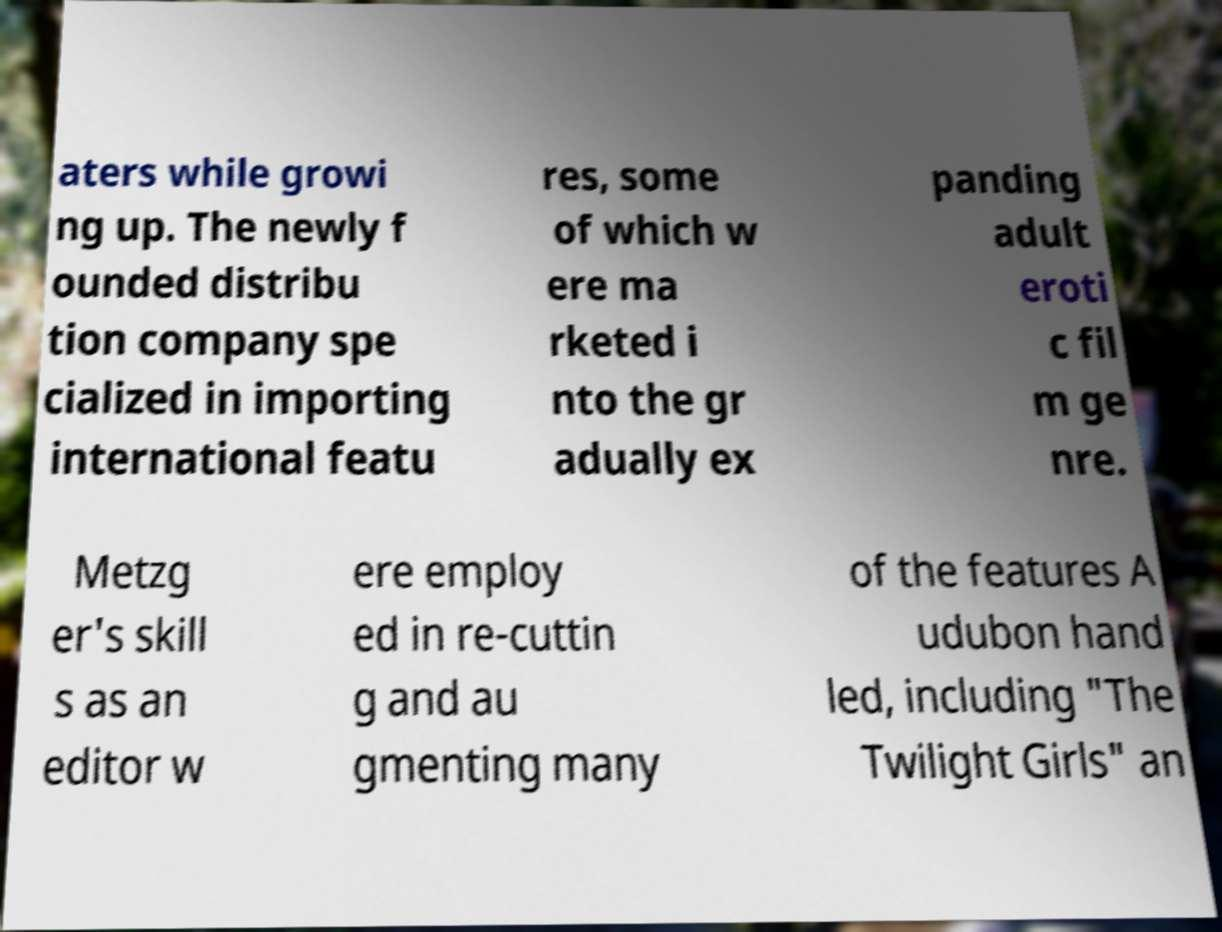For documentation purposes, I need the text within this image transcribed. Could you provide that? aters while growi ng up. The newly f ounded distribu tion company spe cialized in importing international featu res, some of which w ere ma rketed i nto the gr adually ex panding adult eroti c fil m ge nre. Metzg er's skill s as an editor w ere employ ed in re-cuttin g and au gmenting many of the features A udubon hand led, including "The Twilight Girls" an 